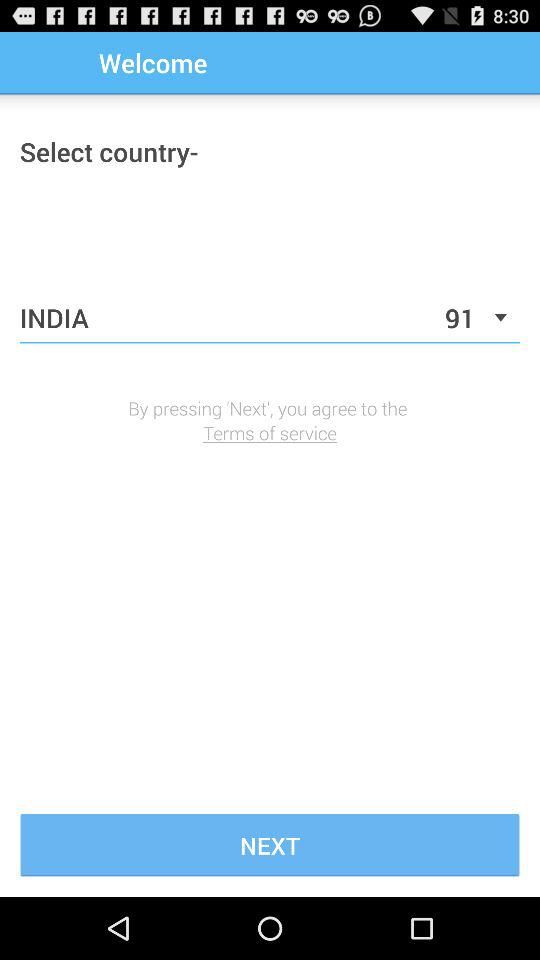What is the country's code? The country's code is 91. 